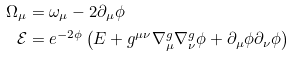Convert formula to latex. <formula><loc_0><loc_0><loc_500><loc_500>\Omega _ { \mu } & = \omega _ { \mu } - 2 \partial _ { \mu } \phi \\ \mathcal { E } & = e ^ { - 2 \phi } \left ( E + g ^ { \mu \nu } \nabla _ { \mu } ^ { g } \nabla _ { \nu } ^ { g } \phi + \partial _ { \mu } \phi \partial _ { \nu } \phi \right )</formula> 